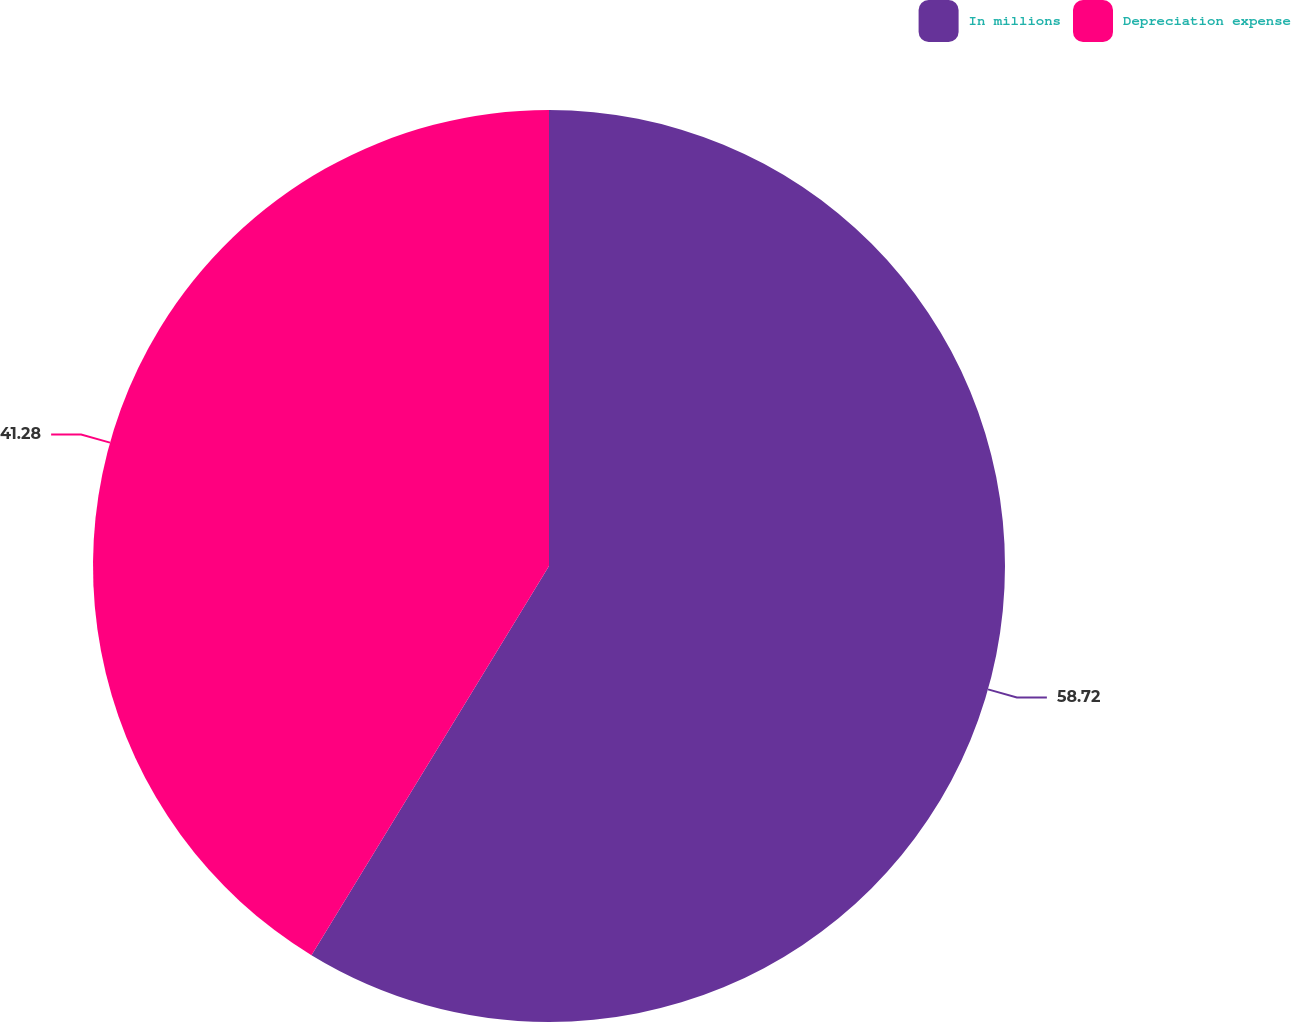<chart> <loc_0><loc_0><loc_500><loc_500><pie_chart><fcel>In millions<fcel>Depreciation expense<nl><fcel>58.72%<fcel>41.28%<nl></chart> 